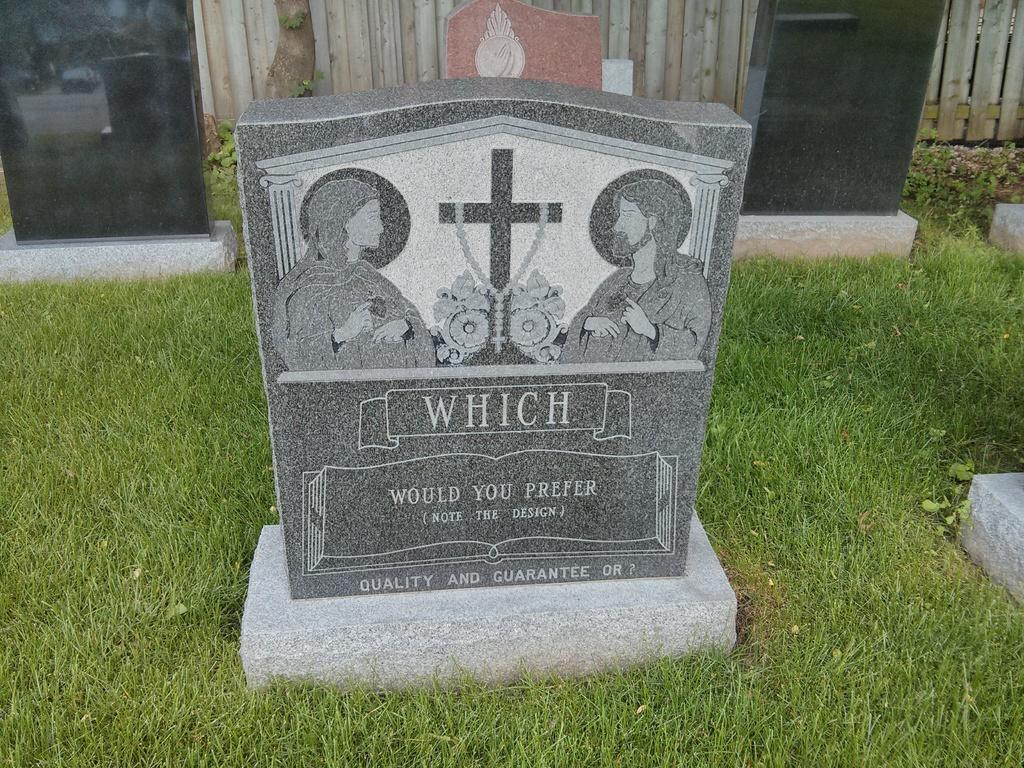In one or two sentences, can you explain what this image depicts? In this picture we can see designed granite. Here we can see women, cross mark, flowers and man. On the bottom we can see grass. In the background we can see other stones, wooden fencing, plants and tree. 